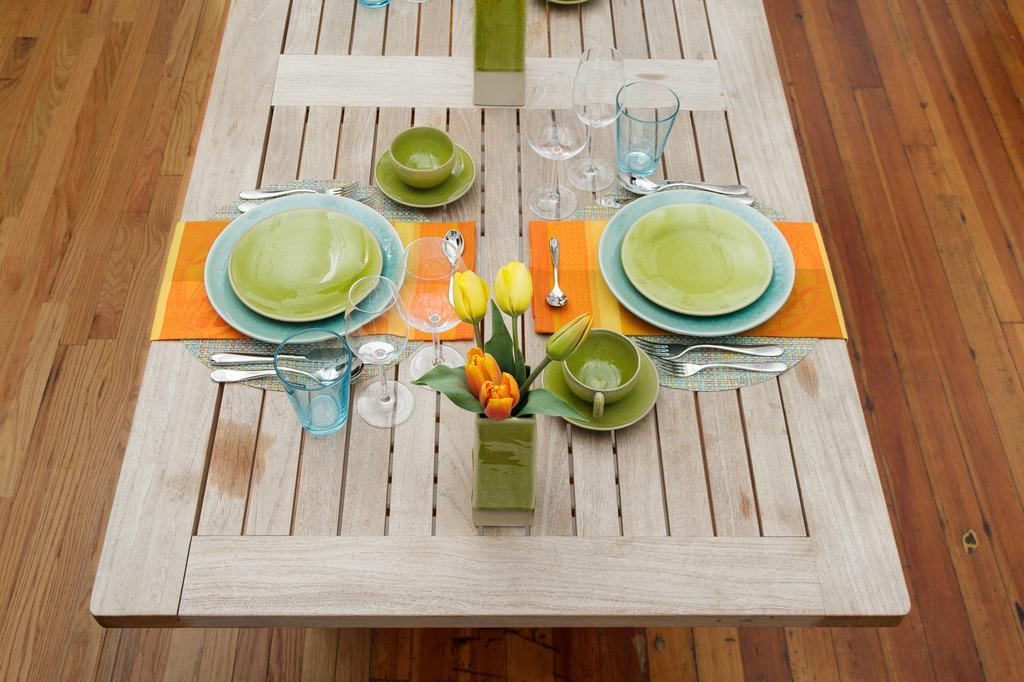In one or two sentences, can you explain what this image depicts? Here we can see empty plates, spoons, forks, a tulip flower vase, water glasses, cup , saucer on the table. This is a floor. 